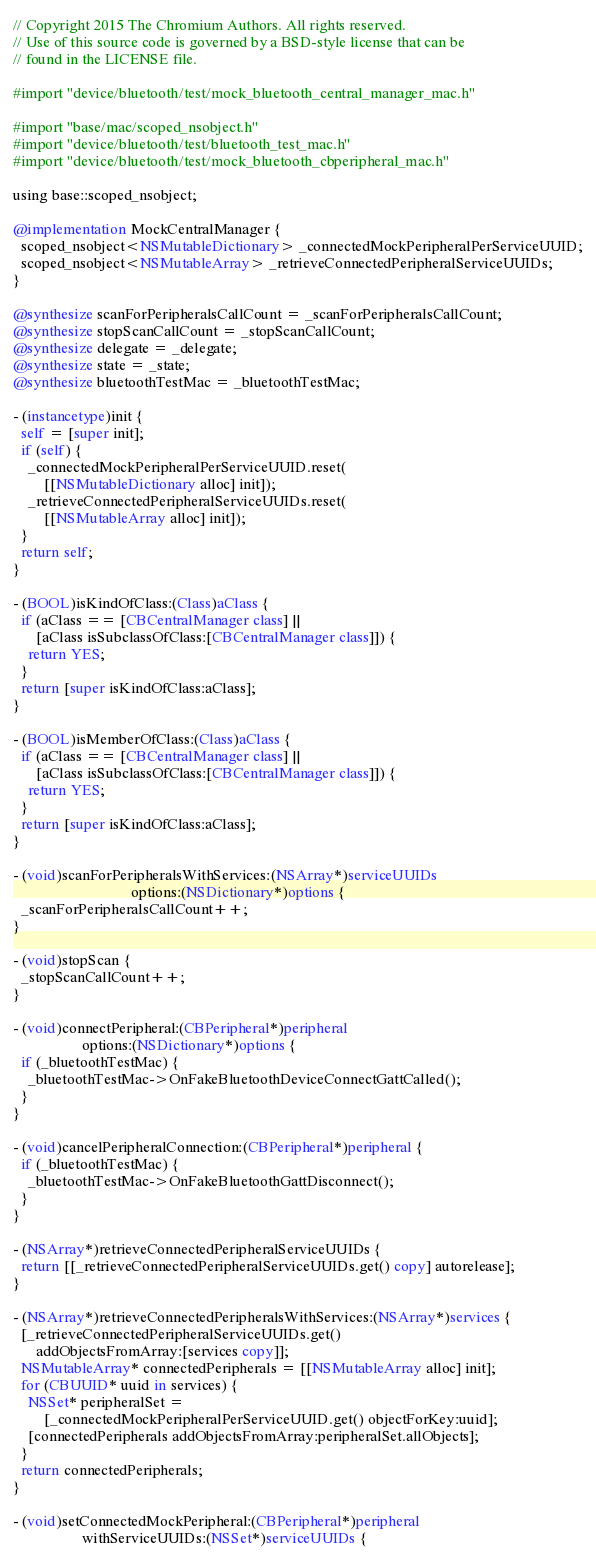Convert code to text. <code><loc_0><loc_0><loc_500><loc_500><_ObjectiveC_>// Copyright 2015 The Chromium Authors. All rights reserved.
// Use of this source code is governed by a BSD-style license that can be
// found in the LICENSE file.

#import "device/bluetooth/test/mock_bluetooth_central_manager_mac.h"

#import "base/mac/scoped_nsobject.h"
#import "device/bluetooth/test/bluetooth_test_mac.h"
#import "device/bluetooth/test/mock_bluetooth_cbperipheral_mac.h"

using base::scoped_nsobject;

@implementation MockCentralManager {
  scoped_nsobject<NSMutableDictionary> _connectedMockPeripheralPerServiceUUID;
  scoped_nsobject<NSMutableArray> _retrieveConnectedPeripheralServiceUUIDs;
}

@synthesize scanForPeripheralsCallCount = _scanForPeripheralsCallCount;
@synthesize stopScanCallCount = _stopScanCallCount;
@synthesize delegate = _delegate;
@synthesize state = _state;
@synthesize bluetoothTestMac = _bluetoothTestMac;

- (instancetype)init {
  self = [super init];
  if (self) {
    _connectedMockPeripheralPerServiceUUID.reset(
        [[NSMutableDictionary alloc] init]);
    _retrieveConnectedPeripheralServiceUUIDs.reset(
        [[NSMutableArray alloc] init]);
  }
  return self;
}

- (BOOL)isKindOfClass:(Class)aClass {
  if (aClass == [CBCentralManager class] ||
      [aClass isSubclassOfClass:[CBCentralManager class]]) {
    return YES;
  }
  return [super isKindOfClass:aClass];
}

- (BOOL)isMemberOfClass:(Class)aClass {
  if (aClass == [CBCentralManager class] ||
      [aClass isSubclassOfClass:[CBCentralManager class]]) {
    return YES;
  }
  return [super isKindOfClass:aClass];
}

- (void)scanForPeripheralsWithServices:(NSArray*)serviceUUIDs
                               options:(NSDictionary*)options {
  _scanForPeripheralsCallCount++;
}

- (void)stopScan {
  _stopScanCallCount++;
}

- (void)connectPeripheral:(CBPeripheral*)peripheral
                  options:(NSDictionary*)options {
  if (_bluetoothTestMac) {
    _bluetoothTestMac->OnFakeBluetoothDeviceConnectGattCalled();
  }
}

- (void)cancelPeripheralConnection:(CBPeripheral*)peripheral {
  if (_bluetoothTestMac) {
    _bluetoothTestMac->OnFakeBluetoothGattDisconnect();
  }
}

- (NSArray*)retrieveConnectedPeripheralServiceUUIDs {
  return [[_retrieveConnectedPeripheralServiceUUIDs.get() copy] autorelease];
}

- (NSArray*)retrieveConnectedPeripheralsWithServices:(NSArray*)services {
  [_retrieveConnectedPeripheralServiceUUIDs.get()
      addObjectsFromArray:[services copy]];
  NSMutableArray* connectedPeripherals = [[NSMutableArray alloc] init];
  for (CBUUID* uuid in services) {
    NSSet* peripheralSet =
        [_connectedMockPeripheralPerServiceUUID.get() objectForKey:uuid];
    [connectedPeripherals addObjectsFromArray:peripheralSet.allObjects];
  }
  return connectedPeripherals;
}

- (void)setConnectedMockPeripheral:(CBPeripheral*)peripheral
                  withServiceUUIDs:(NSSet*)serviceUUIDs {</code> 